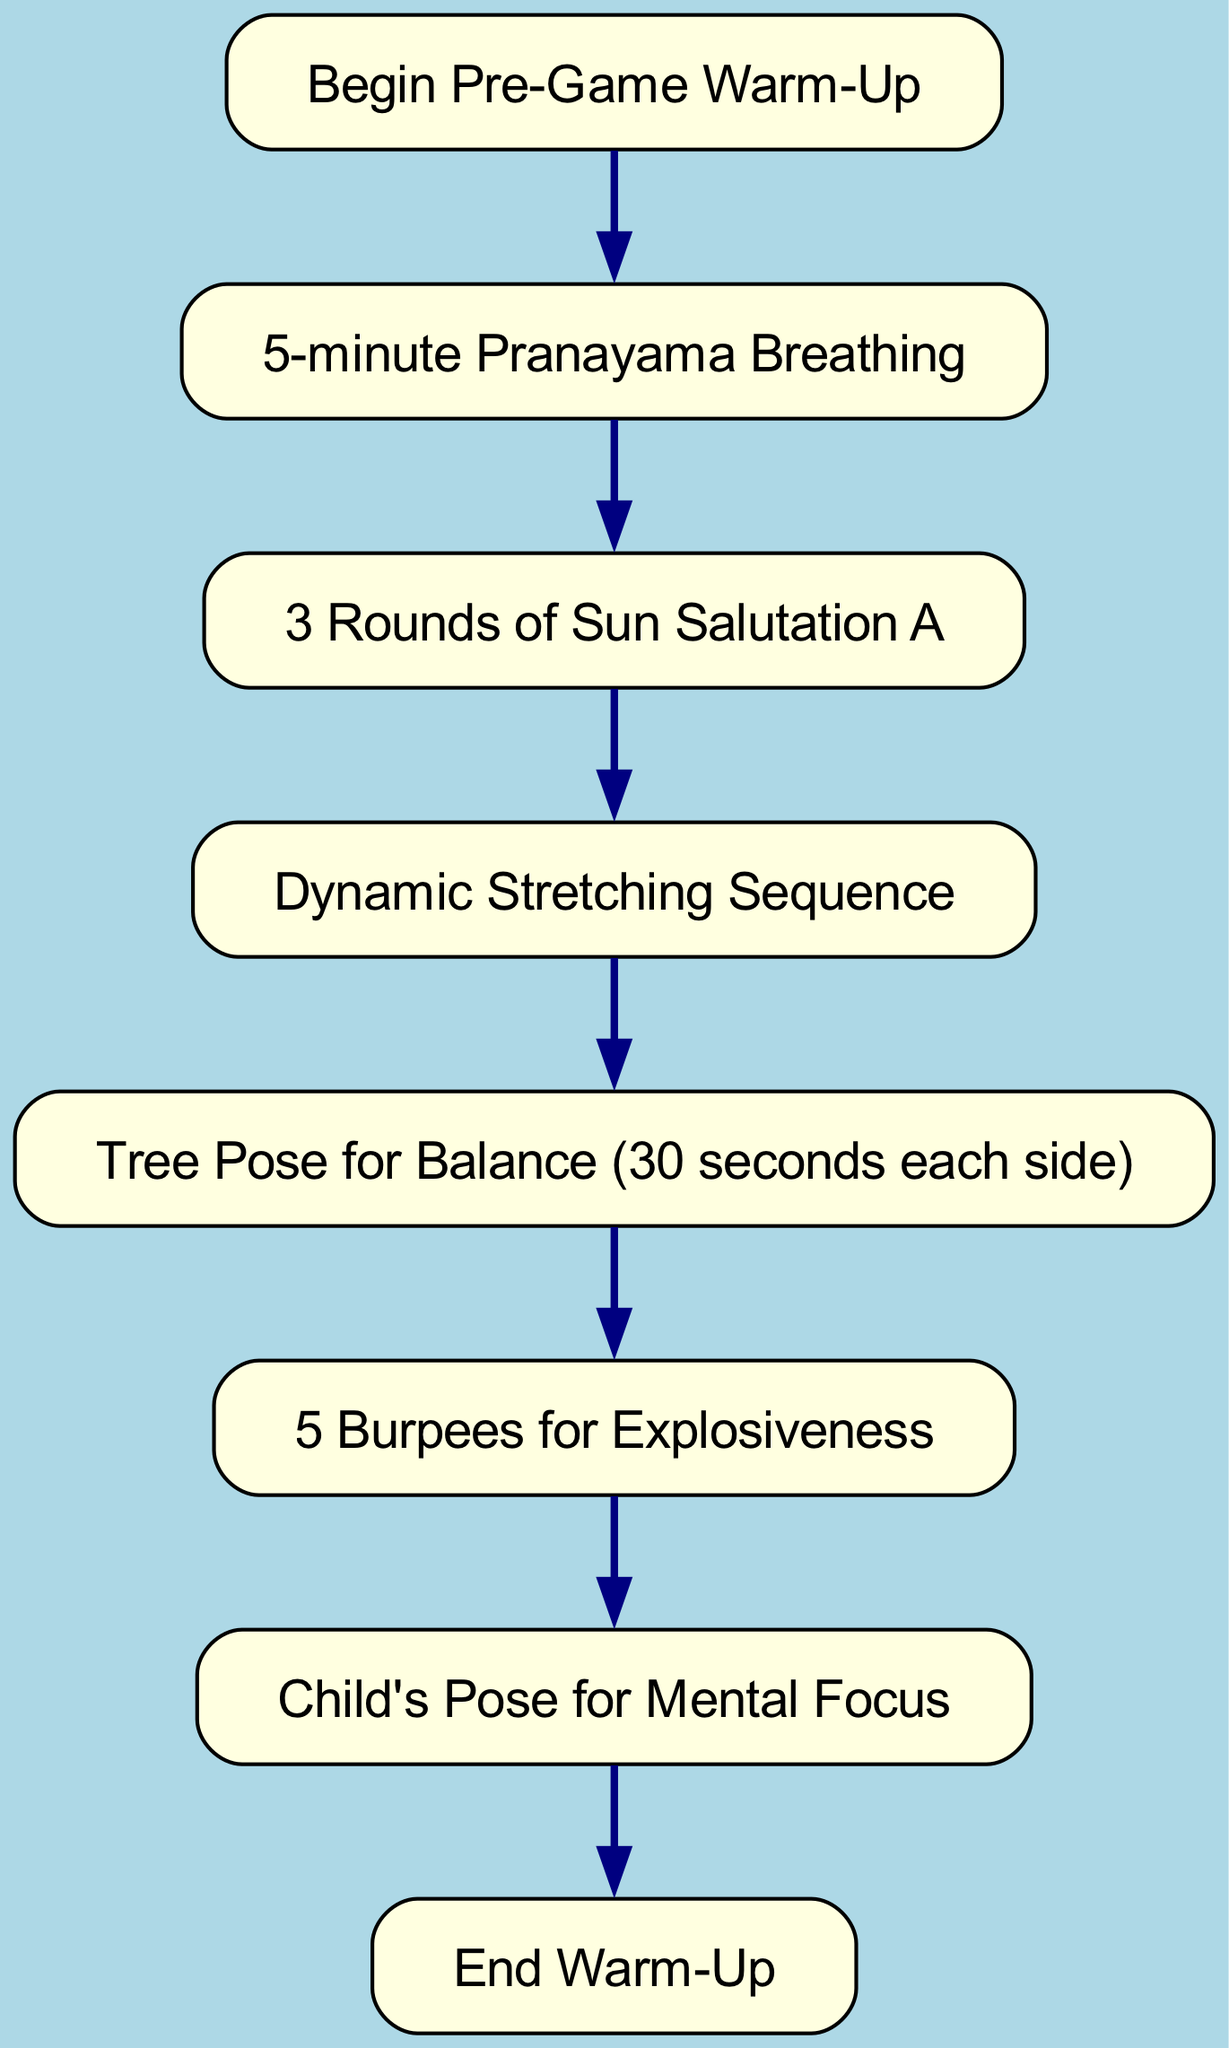What is the first activity in the warm-up routine? The diagram indicates that the first activity after starting the warm-up is "5-minute Pranayama Breathing." This can be seen directly from the first connection branching from the start node.
Answer: 5-minute Pranayama Breathing How many nodes are present in the diagram? The diagram lists a total of 8 distinct nodes, each representing a different step or activity within the warm-up routine. Counting each unique activity from the start to the end gives us this total.
Answer: 8 What is the last activity before concluding the warm-up? The flow chart shows that the last activity before reaching the end node is "Child's Pose for Mental Focus," as it is the final node connected in the sequence.
Answer: Child's Pose for Mental Focus Which activity follows the "Dynamic Stretching Sequence"? Following the "Dynamic Stretching Sequence," according to the diagram, is the "Tree Pose for Balance." This is derived from the direct connection leading from the dynamic stretch node to the balance node.
Answer: Tree Pose for Balance What type of stretching is included in this warm-up routine? The warm-up routine includes "Dynamic Stretching," which is explicitly listed in one of the nodes and is a key component of the pre-game preparation.
Answer: Dynamic Stretching How many times is the "Sun Salutation A" repeated? The diagram indicates "3 Rounds of Sun Salutation A," detailing the specific number of repetitions for this yoga sequence in the warm-up.
Answer: 3 Rounds Which activity emphasizes explosiveness? The "5 Burpees for Explosiveness" is the activity that emphasizes explosiveness, as shown in the flowchart where it follows the balance pose.
Answer: 5 Burpees In what time frame does the entire sequence begin and end? The warm-up sequence begins with "Begin Pre-Game Warm-Up" and ends with "End Warm-Up," establishing the time frame from start to conclusion as indicated by the first and last nodes of the diagram.
Answer: Begin Pre-Game Warm-Up to End Warm-Up 